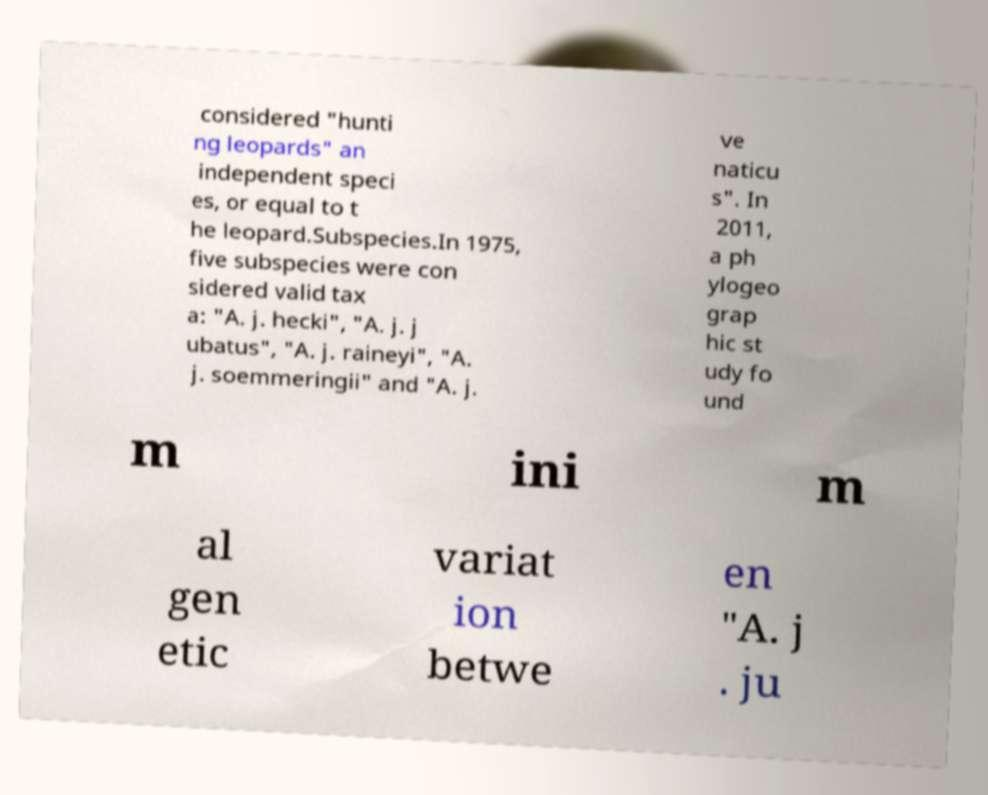Please identify and transcribe the text found in this image. considered "hunti ng leopards" an independent speci es, or equal to t he leopard.Subspecies.In 1975, five subspecies were con sidered valid tax a: "A. j. hecki", "A. j. j ubatus", "A. j. raineyi", "A. j. soemmeringii" and "A. j. ve naticu s". In 2011, a ph ylogeo grap hic st udy fo und m ini m al gen etic variat ion betwe en "A. j . ju 